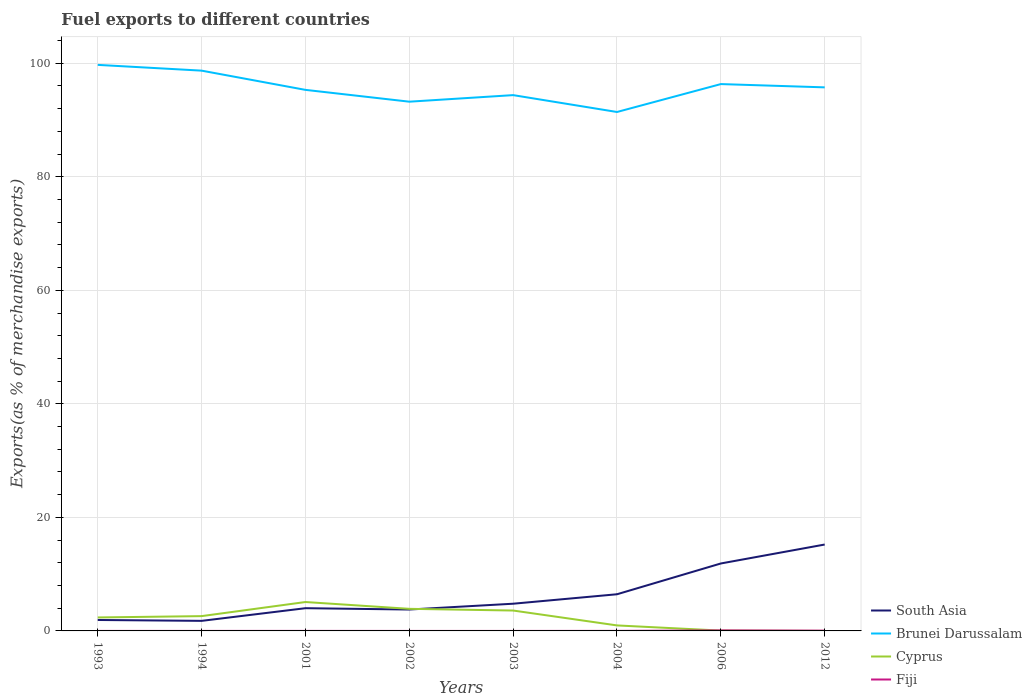Is the number of lines equal to the number of legend labels?
Provide a succinct answer. Yes. Across all years, what is the maximum percentage of exports to different countries in Cyprus?
Provide a succinct answer. 9.987264344271967e-6. In which year was the percentage of exports to different countries in South Asia maximum?
Keep it short and to the point. 1994. What is the total percentage of exports to different countries in South Asia in the graph?
Offer a very short reply. -10.11. What is the difference between the highest and the second highest percentage of exports to different countries in Fiji?
Give a very brief answer. 0.09. Is the percentage of exports to different countries in South Asia strictly greater than the percentage of exports to different countries in Fiji over the years?
Give a very brief answer. No. What is the difference between two consecutive major ticks on the Y-axis?
Ensure brevity in your answer.  20. Does the graph contain grids?
Make the answer very short. Yes. How are the legend labels stacked?
Provide a short and direct response. Vertical. What is the title of the graph?
Your answer should be compact. Fuel exports to different countries. What is the label or title of the Y-axis?
Make the answer very short. Exports(as % of merchandise exports). What is the Exports(as % of merchandise exports) in South Asia in 1993?
Give a very brief answer. 1.93. What is the Exports(as % of merchandise exports) of Brunei Darussalam in 1993?
Keep it short and to the point. 99.71. What is the Exports(as % of merchandise exports) of Cyprus in 1993?
Your answer should be very brief. 2.37. What is the Exports(as % of merchandise exports) in Fiji in 1993?
Your response must be concise. 0. What is the Exports(as % of merchandise exports) in South Asia in 1994?
Offer a terse response. 1.77. What is the Exports(as % of merchandise exports) of Brunei Darussalam in 1994?
Provide a succinct answer. 98.69. What is the Exports(as % of merchandise exports) in Cyprus in 1994?
Offer a very short reply. 2.61. What is the Exports(as % of merchandise exports) of Fiji in 1994?
Keep it short and to the point. 0. What is the Exports(as % of merchandise exports) in South Asia in 2001?
Your answer should be very brief. 4. What is the Exports(as % of merchandise exports) of Brunei Darussalam in 2001?
Your answer should be very brief. 95.31. What is the Exports(as % of merchandise exports) in Cyprus in 2001?
Your response must be concise. 5.09. What is the Exports(as % of merchandise exports) of Fiji in 2001?
Offer a terse response. 0.01. What is the Exports(as % of merchandise exports) in South Asia in 2002?
Your answer should be compact. 3.77. What is the Exports(as % of merchandise exports) of Brunei Darussalam in 2002?
Give a very brief answer. 93.23. What is the Exports(as % of merchandise exports) in Cyprus in 2002?
Offer a very short reply. 3.89. What is the Exports(as % of merchandise exports) of Fiji in 2002?
Your response must be concise. 0. What is the Exports(as % of merchandise exports) of South Asia in 2003?
Offer a very short reply. 4.79. What is the Exports(as % of merchandise exports) in Brunei Darussalam in 2003?
Provide a succinct answer. 94.38. What is the Exports(as % of merchandise exports) in Cyprus in 2003?
Offer a terse response. 3.59. What is the Exports(as % of merchandise exports) in Fiji in 2003?
Provide a short and direct response. 0. What is the Exports(as % of merchandise exports) of South Asia in 2004?
Offer a very short reply. 6.46. What is the Exports(as % of merchandise exports) in Brunei Darussalam in 2004?
Ensure brevity in your answer.  91.41. What is the Exports(as % of merchandise exports) of Cyprus in 2004?
Offer a terse response. 0.97. What is the Exports(as % of merchandise exports) in Fiji in 2004?
Your response must be concise. 0.01. What is the Exports(as % of merchandise exports) of South Asia in 2006?
Ensure brevity in your answer.  11.88. What is the Exports(as % of merchandise exports) in Brunei Darussalam in 2006?
Make the answer very short. 96.33. What is the Exports(as % of merchandise exports) in Cyprus in 2006?
Give a very brief answer. 0.06. What is the Exports(as % of merchandise exports) in Fiji in 2006?
Make the answer very short. 0.09. What is the Exports(as % of merchandise exports) of South Asia in 2012?
Keep it short and to the point. 15.22. What is the Exports(as % of merchandise exports) of Brunei Darussalam in 2012?
Your answer should be compact. 95.75. What is the Exports(as % of merchandise exports) in Cyprus in 2012?
Your answer should be very brief. 9.987264344271967e-6. What is the Exports(as % of merchandise exports) of Fiji in 2012?
Your answer should be very brief. 0.05. Across all years, what is the maximum Exports(as % of merchandise exports) in South Asia?
Keep it short and to the point. 15.22. Across all years, what is the maximum Exports(as % of merchandise exports) in Brunei Darussalam?
Make the answer very short. 99.71. Across all years, what is the maximum Exports(as % of merchandise exports) in Cyprus?
Your answer should be compact. 5.09. Across all years, what is the maximum Exports(as % of merchandise exports) in Fiji?
Make the answer very short. 0.09. Across all years, what is the minimum Exports(as % of merchandise exports) in South Asia?
Offer a terse response. 1.77. Across all years, what is the minimum Exports(as % of merchandise exports) of Brunei Darussalam?
Keep it short and to the point. 91.41. Across all years, what is the minimum Exports(as % of merchandise exports) in Cyprus?
Keep it short and to the point. 9.987264344271967e-6. Across all years, what is the minimum Exports(as % of merchandise exports) in Fiji?
Give a very brief answer. 0. What is the total Exports(as % of merchandise exports) in South Asia in the graph?
Give a very brief answer. 49.82. What is the total Exports(as % of merchandise exports) in Brunei Darussalam in the graph?
Offer a terse response. 764.8. What is the total Exports(as % of merchandise exports) of Cyprus in the graph?
Your answer should be compact. 18.58. What is the total Exports(as % of merchandise exports) in Fiji in the graph?
Your response must be concise. 0.15. What is the difference between the Exports(as % of merchandise exports) in South Asia in 1993 and that in 1994?
Give a very brief answer. 0.15. What is the difference between the Exports(as % of merchandise exports) of Brunei Darussalam in 1993 and that in 1994?
Make the answer very short. 1.02. What is the difference between the Exports(as % of merchandise exports) of Cyprus in 1993 and that in 1994?
Your answer should be compact. -0.24. What is the difference between the Exports(as % of merchandise exports) in Fiji in 1993 and that in 1994?
Provide a succinct answer. 0. What is the difference between the Exports(as % of merchandise exports) in South Asia in 1993 and that in 2001?
Provide a succinct answer. -2.08. What is the difference between the Exports(as % of merchandise exports) in Brunei Darussalam in 1993 and that in 2001?
Your answer should be compact. 4.4. What is the difference between the Exports(as % of merchandise exports) of Cyprus in 1993 and that in 2001?
Your answer should be very brief. -2.72. What is the difference between the Exports(as % of merchandise exports) in Fiji in 1993 and that in 2001?
Your answer should be very brief. -0. What is the difference between the Exports(as % of merchandise exports) of South Asia in 1993 and that in 2002?
Your answer should be very brief. -1.84. What is the difference between the Exports(as % of merchandise exports) of Brunei Darussalam in 1993 and that in 2002?
Keep it short and to the point. 6.48. What is the difference between the Exports(as % of merchandise exports) of Cyprus in 1993 and that in 2002?
Provide a succinct answer. -1.52. What is the difference between the Exports(as % of merchandise exports) of Fiji in 1993 and that in 2002?
Your response must be concise. 0. What is the difference between the Exports(as % of merchandise exports) of South Asia in 1993 and that in 2003?
Your answer should be compact. -2.87. What is the difference between the Exports(as % of merchandise exports) in Brunei Darussalam in 1993 and that in 2003?
Keep it short and to the point. 5.33. What is the difference between the Exports(as % of merchandise exports) in Cyprus in 1993 and that in 2003?
Offer a very short reply. -1.22. What is the difference between the Exports(as % of merchandise exports) in Fiji in 1993 and that in 2003?
Make the answer very short. 0. What is the difference between the Exports(as % of merchandise exports) of South Asia in 1993 and that in 2004?
Ensure brevity in your answer.  -4.53. What is the difference between the Exports(as % of merchandise exports) of Brunei Darussalam in 1993 and that in 2004?
Keep it short and to the point. 8.3. What is the difference between the Exports(as % of merchandise exports) of Cyprus in 1993 and that in 2004?
Offer a terse response. 1.4. What is the difference between the Exports(as % of merchandise exports) of Fiji in 1993 and that in 2004?
Your response must be concise. -0.01. What is the difference between the Exports(as % of merchandise exports) in South Asia in 1993 and that in 2006?
Offer a very short reply. -9.96. What is the difference between the Exports(as % of merchandise exports) in Brunei Darussalam in 1993 and that in 2006?
Your answer should be very brief. 3.38. What is the difference between the Exports(as % of merchandise exports) of Cyprus in 1993 and that in 2006?
Your answer should be very brief. 2.31. What is the difference between the Exports(as % of merchandise exports) in Fiji in 1993 and that in 2006?
Give a very brief answer. -0.09. What is the difference between the Exports(as % of merchandise exports) in South Asia in 1993 and that in 2012?
Give a very brief answer. -13.29. What is the difference between the Exports(as % of merchandise exports) of Brunei Darussalam in 1993 and that in 2012?
Offer a terse response. 3.96. What is the difference between the Exports(as % of merchandise exports) of Cyprus in 1993 and that in 2012?
Your response must be concise. 2.37. What is the difference between the Exports(as % of merchandise exports) in Fiji in 1993 and that in 2012?
Your answer should be compact. -0.04. What is the difference between the Exports(as % of merchandise exports) of South Asia in 1994 and that in 2001?
Offer a terse response. -2.23. What is the difference between the Exports(as % of merchandise exports) in Brunei Darussalam in 1994 and that in 2001?
Provide a succinct answer. 3.39. What is the difference between the Exports(as % of merchandise exports) of Cyprus in 1994 and that in 2001?
Give a very brief answer. -2.48. What is the difference between the Exports(as % of merchandise exports) of Fiji in 1994 and that in 2001?
Make the answer very short. -0. What is the difference between the Exports(as % of merchandise exports) of South Asia in 1994 and that in 2002?
Provide a short and direct response. -2. What is the difference between the Exports(as % of merchandise exports) of Brunei Darussalam in 1994 and that in 2002?
Your answer should be very brief. 5.47. What is the difference between the Exports(as % of merchandise exports) of Cyprus in 1994 and that in 2002?
Make the answer very short. -1.29. What is the difference between the Exports(as % of merchandise exports) in Fiji in 1994 and that in 2002?
Offer a terse response. 0. What is the difference between the Exports(as % of merchandise exports) in South Asia in 1994 and that in 2003?
Make the answer very short. -3.02. What is the difference between the Exports(as % of merchandise exports) of Brunei Darussalam in 1994 and that in 2003?
Provide a short and direct response. 4.31. What is the difference between the Exports(as % of merchandise exports) of Cyprus in 1994 and that in 2003?
Keep it short and to the point. -0.98. What is the difference between the Exports(as % of merchandise exports) in Fiji in 1994 and that in 2003?
Give a very brief answer. 0. What is the difference between the Exports(as % of merchandise exports) of South Asia in 1994 and that in 2004?
Offer a terse response. -4.69. What is the difference between the Exports(as % of merchandise exports) of Brunei Darussalam in 1994 and that in 2004?
Your answer should be compact. 7.28. What is the difference between the Exports(as % of merchandise exports) of Cyprus in 1994 and that in 2004?
Offer a terse response. 1.64. What is the difference between the Exports(as % of merchandise exports) of Fiji in 1994 and that in 2004?
Your answer should be compact. -0.01. What is the difference between the Exports(as % of merchandise exports) in South Asia in 1994 and that in 2006?
Your response must be concise. -10.11. What is the difference between the Exports(as % of merchandise exports) of Brunei Darussalam in 1994 and that in 2006?
Provide a short and direct response. 2.37. What is the difference between the Exports(as % of merchandise exports) in Cyprus in 1994 and that in 2006?
Provide a short and direct response. 2.55. What is the difference between the Exports(as % of merchandise exports) in Fiji in 1994 and that in 2006?
Offer a very short reply. -0.09. What is the difference between the Exports(as % of merchandise exports) of South Asia in 1994 and that in 2012?
Your response must be concise. -13.45. What is the difference between the Exports(as % of merchandise exports) of Brunei Darussalam in 1994 and that in 2012?
Give a very brief answer. 2.95. What is the difference between the Exports(as % of merchandise exports) in Cyprus in 1994 and that in 2012?
Provide a short and direct response. 2.61. What is the difference between the Exports(as % of merchandise exports) in Fiji in 1994 and that in 2012?
Offer a very short reply. -0.04. What is the difference between the Exports(as % of merchandise exports) of South Asia in 2001 and that in 2002?
Your answer should be very brief. 0.23. What is the difference between the Exports(as % of merchandise exports) of Brunei Darussalam in 2001 and that in 2002?
Offer a terse response. 2.08. What is the difference between the Exports(as % of merchandise exports) of Cyprus in 2001 and that in 2002?
Your response must be concise. 1.2. What is the difference between the Exports(as % of merchandise exports) in Fiji in 2001 and that in 2002?
Your answer should be very brief. 0.01. What is the difference between the Exports(as % of merchandise exports) in South Asia in 2001 and that in 2003?
Your answer should be compact. -0.79. What is the difference between the Exports(as % of merchandise exports) in Brunei Darussalam in 2001 and that in 2003?
Provide a succinct answer. 0.92. What is the difference between the Exports(as % of merchandise exports) in Cyprus in 2001 and that in 2003?
Your response must be concise. 1.5. What is the difference between the Exports(as % of merchandise exports) of Fiji in 2001 and that in 2003?
Offer a terse response. 0.01. What is the difference between the Exports(as % of merchandise exports) of South Asia in 2001 and that in 2004?
Offer a terse response. -2.45. What is the difference between the Exports(as % of merchandise exports) of Brunei Darussalam in 2001 and that in 2004?
Offer a terse response. 3.9. What is the difference between the Exports(as % of merchandise exports) of Cyprus in 2001 and that in 2004?
Your answer should be compact. 4.12. What is the difference between the Exports(as % of merchandise exports) of Fiji in 2001 and that in 2004?
Make the answer very short. -0. What is the difference between the Exports(as % of merchandise exports) of South Asia in 2001 and that in 2006?
Ensure brevity in your answer.  -7.88. What is the difference between the Exports(as % of merchandise exports) in Brunei Darussalam in 2001 and that in 2006?
Your response must be concise. -1.02. What is the difference between the Exports(as % of merchandise exports) of Cyprus in 2001 and that in 2006?
Provide a succinct answer. 5.03. What is the difference between the Exports(as % of merchandise exports) of Fiji in 2001 and that in 2006?
Offer a very short reply. -0.08. What is the difference between the Exports(as % of merchandise exports) of South Asia in 2001 and that in 2012?
Give a very brief answer. -11.21. What is the difference between the Exports(as % of merchandise exports) of Brunei Darussalam in 2001 and that in 2012?
Your answer should be very brief. -0.44. What is the difference between the Exports(as % of merchandise exports) in Cyprus in 2001 and that in 2012?
Provide a short and direct response. 5.09. What is the difference between the Exports(as % of merchandise exports) of Fiji in 2001 and that in 2012?
Your answer should be compact. -0.04. What is the difference between the Exports(as % of merchandise exports) of South Asia in 2002 and that in 2003?
Provide a short and direct response. -1.02. What is the difference between the Exports(as % of merchandise exports) of Brunei Darussalam in 2002 and that in 2003?
Offer a very short reply. -1.16. What is the difference between the Exports(as % of merchandise exports) in Cyprus in 2002 and that in 2003?
Ensure brevity in your answer.  0.3. What is the difference between the Exports(as % of merchandise exports) in Fiji in 2002 and that in 2003?
Ensure brevity in your answer.  0. What is the difference between the Exports(as % of merchandise exports) in South Asia in 2002 and that in 2004?
Provide a short and direct response. -2.69. What is the difference between the Exports(as % of merchandise exports) in Brunei Darussalam in 2002 and that in 2004?
Offer a very short reply. 1.82. What is the difference between the Exports(as % of merchandise exports) of Cyprus in 2002 and that in 2004?
Offer a very short reply. 2.92. What is the difference between the Exports(as % of merchandise exports) in Fiji in 2002 and that in 2004?
Your answer should be compact. -0.01. What is the difference between the Exports(as % of merchandise exports) in South Asia in 2002 and that in 2006?
Your answer should be compact. -8.11. What is the difference between the Exports(as % of merchandise exports) in Brunei Darussalam in 2002 and that in 2006?
Keep it short and to the point. -3.1. What is the difference between the Exports(as % of merchandise exports) in Cyprus in 2002 and that in 2006?
Offer a very short reply. 3.84. What is the difference between the Exports(as % of merchandise exports) of Fiji in 2002 and that in 2006?
Provide a succinct answer. -0.09. What is the difference between the Exports(as % of merchandise exports) of South Asia in 2002 and that in 2012?
Your answer should be very brief. -11.45. What is the difference between the Exports(as % of merchandise exports) in Brunei Darussalam in 2002 and that in 2012?
Offer a terse response. -2.52. What is the difference between the Exports(as % of merchandise exports) of Cyprus in 2002 and that in 2012?
Your answer should be compact. 3.89. What is the difference between the Exports(as % of merchandise exports) of Fiji in 2002 and that in 2012?
Keep it short and to the point. -0.05. What is the difference between the Exports(as % of merchandise exports) of South Asia in 2003 and that in 2004?
Give a very brief answer. -1.67. What is the difference between the Exports(as % of merchandise exports) in Brunei Darussalam in 2003 and that in 2004?
Your answer should be compact. 2.97. What is the difference between the Exports(as % of merchandise exports) in Cyprus in 2003 and that in 2004?
Ensure brevity in your answer.  2.62. What is the difference between the Exports(as % of merchandise exports) in Fiji in 2003 and that in 2004?
Give a very brief answer. -0.01. What is the difference between the Exports(as % of merchandise exports) in South Asia in 2003 and that in 2006?
Make the answer very short. -7.09. What is the difference between the Exports(as % of merchandise exports) in Brunei Darussalam in 2003 and that in 2006?
Offer a very short reply. -1.94. What is the difference between the Exports(as % of merchandise exports) of Cyprus in 2003 and that in 2006?
Offer a terse response. 3.53. What is the difference between the Exports(as % of merchandise exports) in Fiji in 2003 and that in 2006?
Your response must be concise. -0.09. What is the difference between the Exports(as % of merchandise exports) of South Asia in 2003 and that in 2012?
Keep it short and to the point. -10.42. What is the difference between the Exports(as % of merchandise exports) of Brunei Darussalam in 2003 and that in 2012?
Your response must be concise. -1.37. What is the difference between the Exports(as % of merchandise exports) in Cyprus in 2003 and that in 2012?
Offer a terse response. 3.59. What is the difference between the Exports(as % of merchandise exports) in Fiji in 2003 and that in 2012?
Your answer should be very brief. -0.05. What is the difference between the Exports(as % of merchandise exports) in South Asia in 2004 and that in 2006?
Your answer should be compact. -5.42. What is the difference between the Exports(as % of merchandise exports) in Brunei Darussalam in 2004 and that in 2006?
Your response must be concise. -4.92. What is the difference between the Exports(as % of merchandise exports) of Cyprus in 2004 and that in 2006?
Provide a short and direct response. 0.91. What is the difference between the Exports(as % of merchandise exports) of Fiji in 2004 and that in 2006?
Your answer should be very brief. -0.08. What is the difference between the Exports(as % of merchandise exports) of South Asia in 2004 and that in 2012?
Your answer should be very brief. -8.76. What is the difference between the Exports(as % of merchandise exports) of Brunei Darussalam in 2004 and that in 2012?
Give a very brief answer. -4.34. What is the difference between the Exports(as % of merchandise exports) in Cyprus in 2004 and that in 2012?
Your response must be concise. 0.97. What is the difference between the Exports(as % of merchandise exports) of Fiji in 2004 and that in 2012?
Keep it short and to the point. -0.04. What is the difference between the Exports(as % of merchandise exports) in South Asia in 2006 and that in 2012?
Your answer should be compact. -3.34. What is the difference between the Exports(as % of merchandise exports) of Brunei Darussalam in 2006 and that in 2012?
Keep it short and to the point. 0.58. What is the difference between the Exports(as % of merchandise exports) of Cyprus in 2006 and that in 2012?
Ensure brevity in your answer.  0.06. What is the difference between the Exports(as % of merchandise exports) of Fiji in 2006 and that in 2012?
Give a very brief answer. 0.04. What is the difference between the Exports(as % of merchandise exports) of South Asia in 1993 and the Exports(as % of merchandise exports) of Brunei Darussalam in 1994?
Give a very brief answer. -96.77. What is the difference between the Exports(as % of merchandise exports) of South Asia in 1993 and the Exports(as % of merchandise exports) of Cyprus in 1994?
Offer a terse response. -0.68. What is the difference between the Exports(as % of merchandise exports) in South Asia in 1993 and the Exports(as % of merchandise exports) in Fiji in 1994?
Your response must be concise. 1.92. What is the difference between the Exports(as % of merchandise exports) in Brunei Darussalam in 1993 and the Exports(as % of merchandise exports) in Cyprus in 1994?
Offer a very short reply. 97.1. What is the difference between the Exports(as % of merchandise exports) in Brunei Darussalam in 1993 and the Exports(as % of merchandise exports) in Fiji in 1994?
Ensure brevity in your answer.  99.71. What is the difference between the Exports(as % of merchandise exports) in Cyprus in 1993 and the Exports(as % of merchandise exports) in Fiji in 1994?
Ensure brevity in your answer.  2.37. What is the difference between the Exports(as % of merchandise exports) in South Asia in 1993 and the Exports(as % of merchandise exports) in Brunei Darussalam in 2001?
Your answer should be compact. -93.38. What is the difference between the Exports(as % of merchandise exports) of South Asia in 1993 and the Exports(as % of merchandise exports) of Cyprus in 2001?
Give a very brief answer. -3.17. What is the difference between the Exports(as % of merchandise exports) of South Asia in 1993 and the Exports(as % of merchandise exports) of Fiji in 2001?
Give a very brief answer. 1.92. What is the difference between the Exports(as % of merchandise exports) in Brunei Darussalam in 1993 and the Exports(as % of merchandise exports) in Cyprus in 2001?
Your response must be concise. 94.62. What is the difference between the Exports(as % of merchandise exports) of Brunei Darussalam in 1993 and the Exports(as % of merchandise exports) of Fiji in 2001?
Your answer should be very brief. 99.7. What is the difference between the Exports(as % of merchandise exports) of Cyprus in 1993 and the Exports(as % of merchandise exports) of Fiji in 2001?
Your response must be concise. 2.37. What is the difference between the Exports(as % of merchandise exports) of South Asia in 1993 and the Exports(as % of merchandise exports) of Brunei Darussalam in 2002?
Make the answer very short. -91.3. What is the difference between the Exports(as % of merchandise exports) of South Asia in 1993 and the Exports(as % of merchandise exports) of Cyprus in 2002?
Offer a terse response. -1.97. What is the difference between the Exports(as % of merchandise exports) of South Asia in 1993 and the Exports(as % of merchandise exports) of Fiji in 2002?
Your response must be concise. 1.92. What is the difference between the Exports(as % of merchandise exports) of Brunei Darussalam in 1993 and the Exports(as % of merchandise exports) of Cyprus in 2002?
Your answer should be compact. 95.82. What is the difference between the Exports(as % of merchandise exports) of Brunei Darussalam in 1993 and the Exports(as % of merchandise exports) of Fiji in 2002?
Give a very brief answer. 99.71. What is the difference between the Exports(as % of merchandise exports) of Cyprus in 1993 and the Exports(as % of merchandise exports) of Fiji in 2002?
Ensure brevity in your answer.  2.37. What is the difference between the Exports(as % of merchandise exports) of South Asia in 1993 and the Exports(as % of merchandise exports) of Brunei Darussalam in 2003?
Ensure brevity in your answer.  -92.46. What is the difference between the Exports(as % of merchandise exports) in South Asia in 1993 and the Exports(as % of merchandise exports) in Cyprus in 2003?
Offer a very short reply. -1.67. What is the difference between the Exports(as % of merchandise exports) of South Asia in 1993 and the Exports(as % of merchandise exports) of Fiji in 2003?
Make the answer very short. 1.92. What is the difference between the Exports(as % of merchandise exports) in Brunei Darussalam in 1993 and the Exports(as % of merchandise exports) in Cyprus in 2003?
Ensure brevity in your answer.  96.12. What is the difference between the Exports(as % of merchandise exports) of Brunei Darussalam in 1993 and the Exports(as % of merchandise exports) of Fiji in 2003?
Make the answer very short. 99.71. What is the difference between the Exports(as % of merchandise exports) in Cyprus in 1993 and the Exports(as % of merchandise exports) in Fiji in 2003?
Offer a very short reply. 2.37. What is the difference between the Exports(as % of merchandise exports) in South Asia in 1993 and the Exports(as % of merchandise exports) in Brunei Darussalam in 2004?
Give a very brief answer. -89.48. What is the difference between the Exports(as % of merchandise exports) in South Asia in 1993 and the Exports(as % of merchandise exports) in Cyprus in 2004?
Provide a succinct answer. 0.96. What is the difference between the Exports(as % of merchandise exports) in South Asia in 1993 and the Exports(as % of merchandise exports) in Fiji in 2004?
Your answer should be very brief. 1.92. What is the difference between the Exports(as % of merchandise exports) of Brunei Darussalam in 1993 and the Exports(as % of merchandise exports) of Cyprus in 2004?
Offer a very short reply. 98.74. What is the difference between the Exports(as % of merchandise exports) of Brunei Darussalam in 1993 and the Exports(as % of merchandise exports) of Fiji in 2004?
Offer a terse response. 99.7. What is the difference between the Exports(as % of merchandise exports) in Cyprus in 1993 and the Exports(as % of merchandise exports) in Fiji in 2004?
Give a very brief answer. 2.36. What is the difference between the Exports(as % of merchandise exports) of South Asia in 1993 and the Exports(as % of merchandise exports) of Brunei Darussalam in 2006?
Provide a succinct answer. -94.4. What is the difference between the Exports(as % of merchandise exports) of South Asia in 1993 and the Exports(as % of merchandise exports) of Cyprus in 2006?
Give a very brief answer. 1.87. What is the difference between the Exports(as % of merchandise exports) in South Asia in 1993 and the Exports(as % of merchandise exports) in Fiji in 2006?
Give a very brief answer. 1.84. What is the difference between the Exports(as % of merchandise exports) of Brunei Darussalam in 1993 and the Exports(as % of merchandise exports) of Cyprus in 2006?
Keep it short and to the point. 99.65. What is the difference between the Exports(as % of merchandise exports) in Brunei Darussalam in 1993 and the Exports(as % of merchandise exports) in Fiji in 2006?
Give a very brief answer. 99.62. What is the difference between the Exports(as % of merchandise exports) of Cyprus in 1993 and the Exports(as % of merchandise exports) of Fiji in 2006?
Provide a succinct answer. 2.28. What is the difference between the Exports(as % of merchandise exports) of South Asia in 1993 and the Exports(as % of merchandise exports) of Brunei Darussalam in 2012?
Your answer should be very brief. -93.82. What is the difference between the Exports(as % of merchandise exports) of South Asia in 1993 and the Exports(as % of merchandise exports) of Cyprus in 2012?
Make the answer very short. 1.93. What is the difference between the Exports(as % of merchandise exports) in South Asia in 1993 and the Exports(as % of merchandise exports) in Fiji in 2012?
Keep it short and to the point. 1.88. What is the difference between the Exports(as % of merchandise exports) in Brunei Darussalam in 1993 and the Exports(as % of merchandise exports) in Cyprus in 2012?
Offer a terse response. 99.71. What is the difference between the Exports(as % of merchandise exports) in Brunei Darussalam in 1993 and the Exports(as % of merchandise exports) in Fiji in 2012?
Ensure brevity in your answer.  99.66. What is the difference between the Exports(as % of merchandise exports) of Cyprus in 1993 and the Exports(as % of merchandise exports) of Fiji in 2012?
Keep it short and to the point. 2.33. What is the difference between the Exports(as % of merchandise exports) of South Asia in 1994 and the Exports(as % of merchandise exports) of Brunei Darussalam in 2001?
Make the answer very short. -93.53. What is the difference between the Exports(as % of merchandise exports) of South Asia in 1994 and the Exports(as % of merchandise exports) of Cyprus in 2001?
Give a very brief answer. -3.32. What is the difference between the Exports(as % of merchandise exports) of South Asia in 1994 and the Exports(as % of merchandise exports) of Fiji in 2001?
Provide a short and direct response. 1.77. What is the difference between the Exports(as % of merchandise exports) of Brunei Darussalam in 1994 and the Exports(as % of merchandise exports) of Cyprus in 2001?
Give a very brief answer. 93.6. What is the difference between the Exports(as % of merchandise exports) of Brunei Darussalam in 1994 and the Exports(as % of merchandise exports) of Fiji in 2001?
Your response must be concise. 98.69. What is the difference between the Exports(as % of merchandise exports) in Cyprus in 1994 and the Exports(as % of merchandise exports) in Fiji in 2001?
Ensure brevity in your answer.  2.6. What is the difference between the Exports(as % of merchandise exports) of South Asia in 1994 and the Exports(as % of merchandise exports) of Brunei Darussalam in 2002?
Your answer should be very brief. -91.45. What is the difference between the Exports(as % of merchandise exports) in South Asia in 1994 and the Exports(as % of merchandise exports) in Cyprus in 2002?
Offer a very short reply. -2.12. What is the difference between the Exports(as % of merchandise exports) in South Asia in 1994 and the Exports(as % of merchandise exports) in Fiji in 2002?
Provide a short and direct response. 1.77. What is the difference between the Exports(as % of merchandise exports) in Brunei Darussalam in 1994 and the Exports(as % of merchandise exports) in Cyprus in 2002?
Give a very brief answer. 94.8. What is the difference between the Exports(as % of merchandise exports) in Brunei Darussalam in 1994 and the Exports(as % of merchandise exports) in Fiji in 2002?
Provide a succinct answer. 98.69. What is the difference between the Exports(as % of merchandise exports) of Cyprus in 1994 and the Exports(as % of merchandise exports) of Fiji in 2002?
Give a very brief answer. 2.61. What is the difference between the Exports(as % of merchandise exports) of South Asia in 1994 and the Exports(as % of merchandise exports) of Brunei Darussalam in 2003?
Your answer should be compact. -92.61. What is the difference between the Exports(as % of merchandise exports) of South Asia in 1994 and the Exports(as % of merchandise exports) of Cyprus in 2003?
Offer a very short reply. -1.82. What is the difference between the Exports(as % of merchandise exports) in South Asia in 1994 and the Exports(as % of merchandise exports) in Fiji in 2003?
Ensure brevity in your answer.  1.77. What is the difference between the Exports(as % of merchandise exports) in Brunei Darussalam in 1994 and the Exports(as % of merchandise exports) in Cyprus in 2003?
Your answer should be very brief. 95.1. What is the difference between the Exports(as % of merchandise exports) of Brunei Darussalam in 1994 and the Exports(as % of merchandise exports) of Fiji in 2003?
Your answer should be very brief. 98.69. What is the difference between the Exports(as % of merchandise exports) of Cyprus in 1994 and the Exports(as % of merchandise exports) of Fiji in 2003?
Keep it short and to the point. 2.61. What is the difference between the Exports(as % of merchandise exports) of South Asia in 1994 and the Exports(as % of merchandise exports) of Brunei Darussalam in 2004?
Ensure brevity in your answer.  -89.64. What is the difference between the Exports(as % of merchandise exports) in South Asia in 1994 and the Exports(as % of merchandise exports) in Cyprus in 2004?
Make the answer very short. 0.8. What is the difference between the Exports(as % of merchandise exports) in South Asia in 1994 and the Exports(as % of merchandise exports) in Fiji in 2004?
Provide a succinct answer. 1.76. What is the difference between the Exports(as % of merchandise exports) of Brunei Darussalam in 1994 and the Exports(as % of merchandise exports) of Cyprus in 2004?
Make the answer very short. 97.72. What is the difference between the Exports(as % of merchandise exports) in Brunei Darussalam in 1994 and the Exports(as % of merchandise exports) in Fiji in 2004?
Make the answer very short. 98.69. What is the difference between the Exports(as % of merchandise exports) of Cyprus in 1994 and the Exports(as % of merchandise exports) of Fiji in 2004?
Provide a short and direct response. 2.6. What is the difference between the Exports(as % of merchandise exports) of South Asia in 1994 and the Exports(as % of merchandise exports) of Brunei Darussalam in 2006?
Your answer should be very brief. -94.55. What is the difference between the Exports(as % of merchandise exports) of South Asia in 1994 and the Exports(as % of merchandise exports) of Cyprus in 2006?
Your response must be concise. 1.71. What is the difference between the Exports(as % of merchandise exports) of South Asia in 1994 and the Exports(as % of merchandise exports) of Fiji in 2006?
Keep it short and to the point. 1.68. What is the difference between the Exports(as % of merchandise exports) of Brunei Darussalam in 1994 and the Exports(as % of merchandise exports) of Cyprus in 2006?
Make the answer very short. 98.64. What is the difference between the Exports(as % of merchandise exports) in Brunei Darussalam in 1994 and the Exports(as % of merchandise exports) in Fiji in 2006?
Your response must be concise. 98.61. What is the difference between the Exports(as % of merchandise exports) of Cyprus in 1994 and the Exports(as % of merchandise exports) of Fiji in 2006?
Ensure brevity in your answer.  2.52. What is the difference between the Exports(as % of merchandise exports) in South Asia in 1994 and the Exports(as % of merchandise exports) in Brunei Darussalam in 2012?
Ensure brevity in your answer.  -93.98. What is the difference between the Exports(as % of merchandise exports) of South Asia in 1994 and the Exports(as % of merchandise exports) of Cyprus in 2012?
Your response must be concise. 1.77. What is the difference between the Exports(as % of merchandise exports) of South Asia in 1994 and the Exports(as % of merchandise exports) of Fiji in 2012?
Your answer should be very brief. 1.73. What is the difference between the Exports(as % of merchandise exports) in Brunei Darussalam in 1994 and the Exports(as % of merchandise exports) in Cyprus in 2012?
Your answer should be very brief. 98.69. What is the difference between the Exports(as % of merchandise exports) of Brunei Darussalam in 1994 and the Exports(as % of merchandise exports) of Fiji in 2012?
Your response must be concise. 98.65. What is the difference between the Exports(as % of merchandise exports) of Cyprus in 1994 and the Exports(as % of merchandise exports) of Fiji in 2012?
Offer a terse response. 2.56. What is the difference between the Exports(as % of merchandise exports) of South Asia in 2001 and the Exports(as % of merchandise exports) of Brunei Darussalam in 2002?
Give a very brief answer. -89.22. What is the difference between the Exports(as % of merchandise exports) of South Asia in 2001 and the Exports(as % of merchandise exports) of Cyprus in 2002?
Make the answer very short. 0.11. What is the difference between the Exports(as % of merchandise exports) of South Asia in 2001 and the Exports(as % of merchandise exports) of Fiji in 2002?
Your answer should be very brief. 4. What is the difference between the Exports(as % of merchandise exports) of Brunei Darussalam in 2001 and the Exports(as % of merchandise exports) of Cyprus in 2002?
Provide a succinct answer. 91.41. What is the difference between the Exports(as % of merchandise exports) of Brunei Darussalam in 2001 and the Exports(as % of merchandise exports) of Fiji in 2002?
Ensure brevity in your answer.  95.31. What is the difference between the Exports(as % of merchandise exports) in Cyprus in 2001 and the Exports(as % of merchandise exports) in Fiji in 2002?
Your answer should be very brief. 5.09. What is the difference between the Exports(as % of merchandise exports) of South Asia in 2001 and the Exports(as % of merchandise exports) of Brunei Darussalam in 2003?
Your answer should be very brief. -90.38. What is the difference between the Exports(as % of merchandise exports) of South Asia in 2001 and the Exports(as % of merchandise exports) of Cyprus in 2003?
Keep it short and to the point. 0.41. What is the difference between the Exports(as % of merchandise exports) in South Asia in 2001 and the Exports(as % of merchandise exports) in Fiji in 2003?
Provide a short and direct response. 4. What is the difference between the Exports(as % of merchandise exports) in Brunei Darussalam in 2001 and the Exports(as % of merchandise exports) in Cyprus in 2003?
Offer a very short reply. 91.71. What is the difference between the Exports(as % of merchandise exports) of Brunei Darussalam in 2001 and the Exports(as % of merchandise exports) of Fiji in 2003?
Your answer should be compact. 95.31. What is the difference between the Exports(as % of merchandise exports) in Cyprus in 2001 and the Exports(as % of merchandise exports) in Fiji in 2003?
Provide a succinct answer. 5.09. What is the difference between the Exports(as % of merchandise exports) of South Asia in 2001 and the Exports(as % of merchandise exports) of Brunei Darussalam in 2004?
Offer a terse response. -87.41. What is the difference between the Exports(as % of merchandise exports) of South Asia in 2001 and the Exports(as % of merchandise exports) of Cyprus in 2004?
Your answer should be very brief. 3.03. What is the difference between the Exports(as % of merchandise exports) of South Asia in 2001 and the Exports(as % of merchandise exports) of Fiji in 2004?
Offer a very short reply. 4. What is the difference between the Exports(as % of merchandise exports) of Brunei Darussalam in 2001 and the Exports(as % of merchandise exports) of Cyprus in 2004?
Your answer should be compact. 94.34. What is the difference between the Exports(as % of merchandise exports) in Brunei Darussalam in 2001 and the Exports(as % of merchandise exports) in Fiji in 2004?
Make the answer very short. 95.3. What is the difference between the Exports(as % of merchandise exports) of Cyprus in 2001 and the Exports(as % of merchandise exports) of Fiji in 2004?
Your answer should be compact. 5.08. What is the difference between the Exports(as % of merchandise exports) in South Asia in 2001 and the Exports(as % of merchandise exports) in Brunei Darussalam in 2006?
Make the answer very short. -92.32. What is the difference between the Exports(as % of merchandise exports) of South Asia in 2001 and the Exports(as % of merchandise exports) of Cyprus in 2006?
Give a very brief answer. 3.95. What is the difference between the Exports(as % of merchandise exports) of South Asia in 2001 and the Exports(as % of merchandise exports) of Fiji in 2006?
Provide a succinct answer. 3.92. What is the difference between the Exports(as % of merchandise exports) of Brunei Darussalam in 2001 and the Exports(as % of merchandise exports) of Cyprus in 2006?
Provide a short and direct response. 95.25. What is the difference between the Exports(as % of merchandise exports) in Brunei Darussalam in 2001 and the Exports(as % of merchandise exports) in Fiji in 2006?
Provide a short and direct response. 95.22. What is the difference between the Exports(as % of merchandise exports) in Cyprus in 2001 and the Exports(as % of merchandise exports) in Fiji in 2006?
Provide a short and direct response. 5. What is the difference between the Exports(as % of merchandise exports) of South Asia in 2001 and the Exports(as % of merchandise exports) of Brunei Darussalam in 2012?
Provide a short and direct response. -91.75. What is the difference between the Exports(as % of merchandise exports) in South Asia in 2001 and the Exports(as % of merchandise exports) in Cyprus in 2012?
Provide a succinct answer. 4. What is the difference between the Exports(as % of merchandise exports) in South Asia in 2001 and the Exports(as % of merchandise exports) in Fiji in 2012?
Provide a short and direct response. 3.96. What is the difference between the Exports(as % of merchandise exports) in Brunei Darussalam in 2001 and the Exports(as % of merchandise exports) in Cyprus in 2012?
Provide a short and direct response. 95.31. What is the difference between the Exports(as % of merchandise exports) of Brunei Darussalam in 2001 and the Exports(as % of merchandise exports) of Fiji in 2012?
Make the answer very short. 95.26. What is the difference between the Exports(as % of merchandise exports) in Cyprus in 2001 and the Exports(as % of merchandise exports) in Fiji in 2012?
Your answer should be very brief. 5.04. What is the difference between the Exports(as % of merchandise exports) of South Asia in 2002 and the Exports(as % of merchandise exports) of Brunei Darussalam in 2003?
Ensure brevity in your answer.  -90.61. What is the difference between the Exports(as % of merchandise exports) in South Asia in 2002 and the Exports(as % of merchandise exports) in Cyprus in 2003?
Your response must be concise. 0.18. What is the difference between the Exports(as % of merchandise exports) in South Asia in 2002 and the Exports(as % of merchandise exports) in Fiji in 2003?
Offer a terse response. 3.77. What is the difference between the Exports(as % of merchandise exports) of Brunei Darussalam in 2002 and the Exports(as % of merchandise exports) of Cyprus in 2003?
Ensure brevity in your answer.  89.63. What is the difference between the Exports(as % of merchandise exports) of Brunei Darussalam in 2002 and the Exports(as % of merchandise exports) of Fiji in 2003?
Give a very brief answer. 93.23. What is the difference between the Exports(as % of merchandise exports) of Cyprus in 2002 and the Exports(as % of merchandise exports) of Fiji in 2003?
Provide a succinct answer. 3.89. What is the difference between the Exports(as % of merchandise exports) in South Asia in 2002 and the Exports(as % of merchandise exports) in Brunei Darussalam in 2004?
Give a very brief answer. -87.64. What is the difference between the Exports(as % of merchandise exports) in South Asia in 2002 and the Exports(as % of merchandise exports) in Cyprus in 2004?
Your answer should be very brief. 2.8. What is the difference between the Exports(as % of merchandise exports) in South Asia in 2002 and the Exports(as % of merchandise exports) in Fiji in 2004?
Your response must be concise. 3.76. What is the difference between the Exports(as % of merchandise exports) of Brunei Darussalam in 2002 and the Exports(as % of merchandise exports) of Cyprus in 2004?
Make the answer very short. 92.26. What is the difference between the Exports(as % of merchandise exports) in Brunei Darussalam in 2002 and the Exports(as % of merchandise exports) in Fiji in 2004?
Your answer should be compact. 93.22. What is the difference between the Exports(as % of merchandise exports) of Cyprus in 2002 and the Exports(as % of merchandise exports) of Fiji in 2004?
Offer a terse response. 3.88. What is the difference between the Exports(as % of merchandise exports) of South Asia in 2002 and the Exports(as % of merchandise exports) of Brunei Darussalam in 2006?
Your answer should be compact. -92.56. What is the difference between the Exports(as % of merchandise exports) of South Asia in 2002 and the Exports(as % of merchandise exports) of Cyprus in 2006?
Your response must be concise. 3.71. What is the difference between the Exports(as % of merchandise exports) of South Asia in 2002 and the Exports(as % of merchandise exports) of Fiji in 2006?
Provide a succinct answer. 3.68. What is the difference between the Exports(as % of merchandise exports) of Brunei Darussalam in 2002 and the Exports(as % of merchandise exports) of Cyprus in 2006?
Keep it short and to the point. 93.17. What is the difference between the Exports(as % of merchandise exports) of Brunei Darussalam in 2002 and the Exports(as % of merchandise exports) of Fiji in 2006?
Your response must be concise. 93.14. What is the difference between the Exports(as % of merchandise exports) in Cyprus in 2002 and the Exports(as % of merchandise exports) in Fiji in 2006?
Your response must be concise. 3.8. What is the difference between the Exports(as % of merchandise exports) of South Asia in 2002 and the Exports(as % of merchandise exports) of Brunei Darussalam in 2012?
Ensure brevity in your answer.  -91.98. What is the difference between the Exports(as % of merchandise exports) of South Asia in 2002 and the Exports(as % of merchandise exports) of Cyprus in 2012?
Ensure brevity in your answer.  3.77. What is the difference between the Exports(as % of merchandise exports) of South Asia in 2002 and the Exports(as % of merchandise exports) of Fiji in 2012?
Your response must be concise. 3.72. What is the difference between the Exports(as % of merchandise exports) of Brunei Darussalam in 2002 and the Exports(as % of merchandise exports) of Cyprus in 2012?
Offer a terse response. 93.23. What is the difference between the Exports(as % of merchandise exports) in Brunei Darussalam in 2002 and the Exports(as % of merchandise exports) in Fiji in 2012?
Provide a succinct answer. 93.18. What is the difference between the Exports(as % of merchandise exports) in Cyprus in 2002 and the Exports(as % of merchandise exports) in Fiji in 2012?
Your response must be concise. 3.85. What is the difference between the Exports(as % of merchandise exports) of South Asia in 2003 and the Exports(as % of merchandise exports) of Brunei Darussalam in 2004?
Your response must be concise. -86.62. What is the difference between the Exports(as % of merchandise exports) of South Asia in 2003 and the Exports(as % of merchandise exports) of Cyprus in 2004?
Your answer should be compact. 3.82. What is the difference between the Exports(as % of merchandise exports) in South Asia in 2003 and the Exports(as % of merchandise exports) in Fiji in 2004?
Keep it short and to the point. 4.78. What is the difference between the Exports(as % of merchandise exports) in Brunei Darussalam in 2003 and the Exports(as % of merchandise exports) in Cyprus in 2004?
Offer a terse response. 93.41. What is the difference between the Exports(as % of merchandise exports) of Brunei Darussalam in 2003 and the Exports(as % of merchandise exports) of Fiji in 2004?
Keep it short and to the point. 94.37. What is the difference between the Exports(as % of merchandise exports) of Cyprus in 2003 and the Exports(as % of merchandise exports) of Fiji in 2004?
Give a very brief answer. 3.58. What is the difference between the Exports(as % of merchandise exports) in South Asia in 2003 and the Exports(as % of merchandise exports) in Brunei Darussalam in 2006?
Ensure brevity in your answer.  -91.53. What is the difference between the Exports(as % of merchandise exports) in South Asia in 2003 and the Exports(as % of merchandise exports) in Cyprus in 2006?
Offer a terse response. 4.73. What is the difference between the Exports(as % of merchandise exports) of South Asia in 2003 and the Exports(as % of merchandise exports) of Fiji in 2006?
Provide a succinct answer. 4.7. What is the difference between the Exports(as % of merchandise exports) in Brunei Darussalam in 2003 and the Exports(as % of merchandise exports) in Cyprus in 2006?
Your answer should be very brief. 94.32. What is the difference between the Exports(as % of merchandise exports) in Brunei Darussalam in 2003 and the Exports(as % of merchandise exports) in Fiji in 2006?
Provide a succinct answer. 94.29. What is the difference between the Exports(as % of merchandise exports) of Cyprus in 2003 and the Exports(as % of merchandise exports) of Fiji in 2006?
Offer a terse response. 3.5. What is the difference between the Exports(as % of merchandise exports) of South Asia in 2003 and the Exports(as % of merchandise exports) of Brunei Darussalam in 2012?
Your response must be concise. -90.96. What is the difference between the Exports(as % of merchandise exports) of South Asia in 2003 and the Exports(as % of merchandise exports) of Cyprus in 2012?
Make the answer very short. 4.79. What is the difference between the Exports(as % of merchandise exports) of South Asia in 2003 and the Exports(as % of merchandise exports) of Fiji in 2012?
Provide a succinct answer. 4.75. What is the difference between the Exports(as % of merchandise exports) of Brunei Darussalam in 2003 and the Exports(as % of merchandise exports) of Cyprus in 2012?
Your answer should be compact. 94.38. What is the difference between the Exports(as % of merchandise exports) in Brunei Darussalam in 2003 and the Exports(as % of merchandise exports) in Fiji in 2012?
Your response must be concise. 94.34. What is the difference between the Exports(as % of merchandise exports) in Cyprus in 2003 and the Exports(as % of merchandise exports) in Fiji in 2012?
Make the answer very short. 3.55. What is the difference between the Exports(as % of merchandise exports) of South Asia in 2004 and the Exports(as % of merchandise exports) of Brunei Darussalam in 2006?
Keep it short and to the point. -89.87. What is the difference between the Exports(as % of merchandise exports) of South Asia in 2004 and the Exports(as % of merchandise exports) of Cyprus in 2006?
Provide a short and direct response. 6.4. What is the difference between the Exports(as % of merchandise exports) in South Asia in 2004 and the Exports(as % of merchandise exports) in Fiji in 2006?
Provide a succinct answer. 6.37. What is the difference between the Exports(as % of merchandise exports) in Brunei Darussalam in 2004 and the Exports(as % of merchandise exports) in Cyprus in 2006?
Ensure brevity in your answer.  91.35. What is the difference between the Exports(as % of merchandise exports) in Brunei Darussalam in 2004 and the Exports(as % of merchandise exports) in Fiji in 2006?
Offer a terse response. 91.32. What is the difference between the Exports(as % of merchandise exports) of Cyprus in 2004 and the Exports(as % of merchandise exports) of Fiji in 2006?
Offer a very short reply. 0.88. What is the difference between the Exports(as % of merchandise exports) of South Asia in 2004 and the Exports(as % of merchandise exports) of Brunei Darussalam in 2012?
Offer a terse response. -89.29. What is the difference between the Exports(as % of merchandise exports) of South Asia in 2004 and the Exports(as % of merchandise exports) of Cyprus in 2012?
Keep it short and to the point. 6.46. What is the difference between the Exports(as % of merchandise exports) of South Asia in 2004 and the Exports(as % of merchandise exports) of Fiji in 2012?
Give a very brief answer. 6.41. What is the difference between the Exports(as % of merchandise exports) of Brunei Darussalam in 2004 and the Exports(as % of merchandise exports) of Cyprus in 2012?
Make the answer very short. 91.41. What is the difference between the Exports(as % of merchandise exports) in Brunei Darussalam in 2004 and the Exports(as % of merchandise exports) in Fiji in 2012?
Ensure brevity in your answer.  91.36. What is the difference between the Exports(as % of merchandise exports) of Cyprus in 2004 and the Exports(as % of merchandise exports) of Fiji in 2012?
Your response must be concise. 0.92. What is the difference between the Exports(as % of merchandise exports) in South Asia in 2006 and the Exports(as % of merchandise exports) in Brunei Darussalam in 2012?
Offer a very short reply. -83.87. What is the difference between the Exports(as % of merchandise exports) in South Asia in 2006 and the Exports(as % of merchandise exports) in Cyprus in 2012?
Your response must be concise. 11.88. What is the difference between the Exports(as % of merchandise exports) of South Asia in 2006 and the Exports(as % of merchandise exports) of Fiji in 2012?
Make the answer very short. 11.84. What is the difference between the Exports(as % of merchandise exports) of Brunei Darussalam in 2006 and the Exports(as % of merchandise exports) of Cyprus in 2012?
Make the answer very short. 96.33. What is the difference between the Exports(as % of merchandise exports) of Brunei Darussalam in 2006 and the Exports(as % of merchandise exports) of Fiji in 2012?
Your answer should be compact. 96.28. What is the difference between the Exports(as % of merchandise exports) of Cyprus in 2006 and the Exports(as % of merchandise exports) of Fiji in 2012?
Your answer should be compact. 0.01. What is the average Exports(as % of merchandise exports) in South Asia per year?
Offer a terse response. 6.23. What is the average Exports(as % of merchandise exports) in Brunei Darussalam per year?
Give a very brief answer. 95.6. What is the average Exports(as % of merchandise exports) in Cyprus per year?
Keep it short and to the point. 2.32. What is the average Exports(as % of merchandise exports) of Fiji per year?
Your response must be concise. 0.02. In the year 1993, what is the difference between the Exports(as % of merchandise exports) in South Asia and Exports(as % of merchandise exports) in Brunei Darussalam?
Give a very brief answer. -97.78. In the year 1993, what is the difference between the Exports(as % of merchandise exports) in South Asia and Exports(as % of merchandise exports) in Cyprus?
Your answer should be compact. -0.45. In the year 1993, what is the difference between the Exports(as % of merchandise exports) in South Asia and Exports(as % of merchandise exports) in Fiji?
Offer a terse response. 1.92. In the year 1993, what is the difference between the Exports(as % of merchandise exports) of Brunei Darussalam and Exports(as % of merchandise exports) of Cyprus?
Make the answer very short. 97.34. In the year 1993, what is the difference between the Exports(as % of merchandise exports) of Brunei Darussalam and Exports(as % of merchandise exports) of Fiji?
Your response must be concise. 99.71. In the year 1993, what is the difference between the Exports(as % of merchandise exports) of Cyprus and Exports(as % of merchandise exports) of Fiji?
Your answer should be compact. 2.37. In the year 1994, what is the difference between the Exports(as % of merchandise exports) in South Asia and Exports(as % of merchandise exports) in Brunei Darussalam?
Your answer should be compact. -96.92. In the year 1994, what is the difference between the Exports(as % of merchandise exports) of South Asia and Exports(as % of merchandise exports) of Cyprus?
Provide a short and direct response. -0.83. In the year 1994, what is the difference between the Exports(as % of merchandise exports) of South Asia and Exports(as % of merchandise exports) of Fiji?
Ensure brevity in your answer.  1.77. In the year 1994, what is the difference between the Exports(as % of merchandise exports) in Brunei Darussalam and Exports(as % of merchandise exports) in Cyprus?
Your answer should be very brief. 96.09. In the year 1994, what is the difference between the Exports(as % of merchandise exports) of Brunei Darussalam and Exports(as % of merchandise exports) of Fiji?
Provide a succinct answer. 98.69. In the year 1994, what is the difference between the Exports(as % of merchandise exports) in Cyprus and Exports(as % of merchandise exports) in Fiji?
Your answer should be very brief. 2.61. In the year 2001, what is the difference between the Exports(as % of merchandise exports) in South Asia and Exports(as % of merchandise exports) in Brunei Darussalam?
Give a very brief answer. -91.3. In the year 2001, what is the difference between the Exports(as % of merchandise exports) in South Asia and Exports(as % of merchandise exports) in Cyprus?
Ensure brevity in your answer.  -1.09. In the year 2001, what is the difference between the Exports(as % of merchandise exports) in South Asia and Exports(as % of merchandise exports) in Fiji?
Provide a succinct answer. 4. In the year 2001, what is the difference between the Exports(as % of merchandise exports) in Brunei Darussalam and Exports(as % of merchandise exports) in Cyprus?
Your answer should be compact. 90.22. In the year 2001, what is the difference between the Exports(as % of merchandise exports) in Brunei Darussalam and Exports(as % of merchandise exports) in Fiji?
Offer a very short reply. 95.3. In the year 2001, what is the difference between the Exports(as % of merchandise exports) in Cyprus and Exports(as % of merchandise exports) in Fiji?
Provide a short and direct response. 5.08. In the year 2002, what is the difference between the Exports(as % of merchandise exports) in South Asia and Exports(as % of merchandise exports) in Brunei Darussalam?
Provide a succinct answer. -89.46. In the year 2002, what is the difference between the Exports(as % of merchandise exports) in South Asia and Exports(as % of merchandise exports) in Cyprus?
Offer a terse response. -0.12. In the year 2002, what is the difference between the Exports(as % of merchandise exports) of South Asia and Exports(as % of merchandise exports) of Fiji?
Ensure brevity in your answer.  3.77. In the year 2002, what is the difference between the Exports(as % of merchandise exports) of Brunei Darussalam and Exports(as % of merchandise exports) of Cyprus?
Provide a succinct answer. 89.33. In the year 2002, what is the difference between the Exports(as % of merchandise exports) in Brunei Darussalam and Exports(as % of merchandise exports) in Fiji?
Make the answer very short. 93.22. In the year 2002, what is the difference between the Exports(as % of merchandise exports) of Cyprus and Exports(as % of merchandise exports) of Fiji?
Provide a short and direct response. 3.89. In the year 2003, what is the difference between the Exports(as % of merchandise exports) in South Asia and Exports(as % of merchandise exports) in Brunei Darussalam?
Your answer should be very brief. -89.59. In the year 2003, what is the difference between the Exports(as % of merchandise exports) of South Asia and Exports(as % of merchandise exports) of Cyprus?
Offer a very short reply. 1.2. In the year 2003, what is the difference between the Exports(as % of merchandise exports) in South Asia and Exports(as % of merchandise exports) in Fiji?
Provide a short and direct response. 4.79. In the year 2003, what is the difference between the Exports(as % of merchandise exports) of Brunei Darussalam and Exports(as % of merchandise exports) of Cyprus?
Your response must be concise. 90.79. In the year 2003, what is the difference between the Exports(as % of merchandise exports) of Brunei Darussalam and Exports(as % of merchandise exports) of Fiji?
Your answer should be compact. 94.38. In the year 2003, what is the difference between the Exports(as % of merchandise exports) in Cyprus and Exports(as % of merchandise exports) in Fiji?
Your response must be concise. 3.59. In the year 2004, what is the difference between the Exports(as % of merchandise exports) of South Asia and Exports(as % of merchandise exports) of Brunei Darussalam?
Your response must be concise. -84.95. In the year 2004, what is the difference between the Exports(as % of merchandise exports) of South Asia and Exports(as % of merchandise exports) of Cyprus?
Make the answer very short. 5.49. In the year 2004, what is the difference between the Exports(as % of merchandise exports) in South Asia and Exports(as % of merchandise exports) in Fiji?
Offer a terse response. 6.45. In the year 2004, what is the difference between the Exports(as % of merchandise exports) in Brunei Darussalam and Exports(as % of merchandise exports) in Cyprus?
Your answer should be compact. 90.44. In the year 2004, what is the difference between the Exports(as % of merchandise exports) of Brunei Darussalam and Exports(as % of merchandise exports) of Fiji?
Your answer should be compact. 91.4. In the year 2004, what is the difference between the Exports(as % of merchandise exports) in Cyprus and Exports(as % of merchandise exports) in Fiji?
Your answer should be compact. 0.96. In the year 2006, what is the difference between the Exports(as % of merchandise exports) of South Asia and Exports(as % of merchandise exports) of Brunei Darussalam?
Keep it short and to the point. -84.44. In the year 2006, what is the difference between the Exports(as % of merchandise exports) of South Asia and Exports(as % of merchandise exports) of Cyprus?
Give a very brief answer. 11.82. In the year 2006, what is the difference between the Exports(as % of merchandise exports) in South Asia and Exports(as % of merchandise exports) in Fiji?
Your response must be concise. 11.79. In the year 2006, what is the difference between the Exports(as % of merchandise exports) in Brunei Darussalam and Exports(as % of merchandise exports) in Cyprus?
Keep it short and to the point. 96.27. In the year 2006, what is the difference between the Exports(as % of merchandise exports) of Brunei Darussalam and Exports(as % of merchandise exports) of Fiji?
Your answer should be compact. 96.24. In the year 2006, what is the difference between the Exports(as % of merchandise exports) of Cyprus and Exports(as % of merchandise exports) of Fiji?
Your response must be concise. -0.03. In the year 2012, what is the difference between the Exports(as % of merchandise exports) in South Asia and Exports(as % of merchandise exports) in Brunei Darussalam?
Your answer should be very brief. -80.53. In the year 2012, what is the difference between the Exports(as % of merchandise exports) in South Asia and Exports(as % of merchandise exports) in Cyprus?
Give a very brief answer. 15.22. In the year 2012, what is the difference between the Exports(as % of merchandise exports) of South Asia and Exports(as % of merchandise exports) of Fiji?
Your answer should be very brief. 15.17. In the year 2012, what is the difference between the Exports(as % of merchandise exports) in Brunei Darussalam and Exports(as % of merchandise exports) in Cyprus?
Offer a terse response. 95.75. In the year 2012, what is the difference between the Exports(as % of merchandise exports) in Brunei Darussalam and Exports(as % of merchandise exports) in Fiji?
Your answer should be very brief. 95.7. In the year 2012, what is the difference between the Exports(as % of merchandise exports) of Cyprus and Exports(as % of merchandise exports) of Fiji?
Your answer should be compact. -0.05. What is the ratio of the Exports(as % of merchandise exports) in South Asia in 1993 to that in 1994?
Keep it short and to the point. 1.09. What is the ratio of the Exports(as % of merchandise exports) in Brunei Darussalam in 1993 to that in 1994?
Provide a succinct answer. 1.01. What is the ratio of the Exports(as % of merchandise exports) of Cyprus in 1993 to that in 1994?
Provide a succinct answer. 0.91. What is the ratio of the Exports(as % of merchandise exports) in Fiji in 1993 to that in 1994?
Your answer should be compact. 1.03. What is the ratio of the Exports(as % of merchandise exports) of South Asia in 1993 to that in 2001?
Offer a very short reply. 0.48. What is the ratio of the Exports(as % of merchandise exports) in Brunei Darussalam in 1993 to that in 2001?
Your answer should be very brief. 1.05. What is the ratio of the Exports(as % of merchandise exports) in Cyprus in 1993 to that in 2001?
Ensure brevity in your answer.  0.47. What is the ratio of the Exports(as % of merchandise exports) of Fiji in 1993 to that in 2001?
Make the answer very short. 0.23. What is the ratio of the Exports(as % of merchandise exports) of South Asia in 1993 to that in 2002?
Your answer should be compact. 0.51. What is the ratio of the Exports(as % of merchandise exports) in Brunei Darussalam in 1993 to that in 2002?
Your answer should be compact. 1.07. What is the ratio of the Exports(as % of merchandise exports) in Cyprus in 1993 to that in 2002?
Ensure brevity in your answer.  0.61. What is the ratio of the Exports(as % of merchandise exports) in Fiji in 1993 to that in 2002?
Offer a very short reply. 1.95. What is the ratio of the Exports(as % of merchandise exports) in South Asia in 1993 to that in 2003?
Your answer should be compact. 0.4. What is the ratio of the Exports(as % of merchandise exports) of Brunei Darussalam in 1993 to that in 2003?
Provide a succinct answer. 1.06. What is the ratio of the Exports(as % of merchandise exports) in Cyprus in 1993 to that in 2003?
Provide a short and direct response. 0.66. What is the ratio of the Exports(as % of merchandise exports) of Fiji in 1993 to that in 2003?
Provide a succinct answer. 2.98. What is the ratio of the Exports(as % of merchandise exports) of South Asia in 1993 to that in 2004?
Give a very brief answer. 0.3. What is the ratio of the Exports(as % of merchandise exports) of Brunei Darussalam in 1993 to that in 2004?
Make the answer very short. 1.09. What is the ratio of the Exports(as % of merchandise exports) of Cyprus in 1993 to that in 2004?
Your response must be concise. 2.45. What is the ratio of the Exports(as % of merchandise exports) of Fiji in 1993 to that in 2004?
Provide a short and direct response. 0.17. What is the ratio of the Exports(as % of merchandise exports) in South Asia in 1993 to that in 2006?
Keep it short and to the point. 0.16. What is the ratio of the Exports(as % of merchandise exports) of Brunei Darussalam in 1993 to that in 2006?
Offer a terse response. 1.04. What is the ratio of the Exports(as % of merchandise exports) in Cyprus in 1993 to that in 2006?
Offer a terse response. 41.24. What is the ratio of the Exports(as % of merchandise exports) in Fiji in 1993 to that in 2006?
Your answer should be compact. 0.02. What is the ratio of the Exports(as % of merchandise exports) in South Asia in 1993 to that in 2012?
Provide a short and direct response. 0.13. What is the ratio of the Exports(as % of merchandise exports) in Brunei Darussalam in 1993 to that in 2012?
Offer a terse response. 1.04. What is the ratio of the Exports(as % of merchandise exports) of Cyprus in 1993 to that in 2012?
Your answer should be compact. 2.37e+05. What is the ratio of the Exports(as % of merchandise exports) of Fiji in 1993 to that in 2012?
Make the answer very short. 0.03. What is the ratio of the Exports(as % of merchandise exports) of South Asia in 1994 to that in 2001?
Give a very brief answer. 0.44. What is the ratio of the Exports(as % of merchandise exports) in Brunei Darussalam in 1994 to that in 2001?
Make the answer very short. 1.04. What is the ratio of the Exports(as % of merchandise exports) in Cyprus in 1994 to that in 2001?
Your answer should be very brief. 0.51. What is the ratio of the Exports(as % of merchandise exports) of Fiji in 1994 to that in 2001?
Give a very brief answer. 0.22. What is the ratio of the Exports(as % of merchandise exports) of South Asia in 1994 to that in 2002?
Provide a succinct answer. 0.47. What is the ratio of the Exports(as % of merchandise exports) in Brunei Darussalam in 1994 to that in 2002?
Make the answer very short. 1.06. What is the ratio of the Exports(as % of merchandise exports) of Cyprus in 1994 to that in 2002?
Provide a succinct answer. 0.67. What is the ratio of the Exports(as % of merchandise exports) of Fiji in 1994 to that in 2002?
Offer a terse response. 1.89. What is the ratio of the Exports(as % of merchandise exports) of South Asia in 1994 to that in 2003?
Your response must be concise. 0.37. What is the ratio of the Exports(as % of merchandise exports) of Brunei Darussalam in 1994 to that in 2003?
Provide a succinct answer. 1.05. What is the ratio of the Exports(as % of merchandise exports) of Cyprus in 1994 to that in 2003?
Give a very brief answer. 0.73. What is the ratio of the Exports(as % of merchandise exports) in Fiji in 1994 to that in 2003?
Offer a very short reply. 2.88. What is the ratio of the Exports(as % of merchandise exports) in South Asia in 1994 to that in 2004?
Ensure brevity in your answer.  0.27. What is the ratio of the Exports(as % of merchandise exports) of Brunei Darussalam in 1994 to that in 2004?
Provide a succinct answer. 1.08. What is the ratio of the Exports(as % of merchandise exports) of Cyprus in 1994 to that in 2004?
Your response must be concise. 2.69. What is the ratio of the Exports(as % of merchandise exports) of Fiji in 1994 to that in 2004?
Offer a very short reply. 0.16. What is the ratio of the Exports(as % of merchandise exports) of South Asia in 1994 to that in 2006?
Offer a terse response. 0.15. What is the ratio of the Exports(as % of merchandise exports) of Brunei Darussalam in 1994 to that in 2006?
Your answer should be very brief. 1.02. What is the ratio of the Exports(as % of merchandise exports) in Cyprus in 1994 to that in 2006?
Offer a terse response. 45.33. What is the ratio of the Exports(as % of merchandise exports) of Fiji in 1994 to that in 2006?
Your answer should be compact. 0.02. What is the ratio of the Exports(as % of merchandise exports) of South Asia in 1994 to that in 2012?
Keep it short and to the point. 0.12. What is the ratio of the Exports(as % of merchandise exports) of Brunei Darussalam in 1994 to that in 2012?
Offer a very short reply. 1.03. What is the ratio of the Exports(as % of merchandise exports) of Cyprus in 1994 to that in 2012?
Keep it short and to the point. 2.61e+05. What is the ratio of the Exports(as % of merchandise exports) in Fiji in 1994 to that in 2012?
Offer a terse response. 0.03. What is the ratio of the Exports(as % of merchandise exports) of South Asia in 2001 to that in 2002?
Offer a terse response. 1.06. What is the ratio of the Exports(as % of merchandise exports) of Brunei Darussalam in 2001 to that in 2002?
Keep it short and to the point. 1.02. What is the ratio of the Exports(as % of merchandise exports) in Cyprus in 2001 to that in 2002?
Your response must be concise. 1.31. What is the ratio of the Exports(as % of merchandise exports) of Fiji in 2001 to that in 2002?
Provide a succinct answer. 8.51. What is the ratio of the Exports(as % of merchandise exports) of South Asia in 2001 to that in 2003?
Your response must be concise. 0.84. What is the ratio of the Exports(as % of merchandise exports) of Brunei Darussalam in 2001 to that in 2003?
Ensure brevity in your answer.  1.01. What is the ratio of the Exports(as % of merchandise exports) in Cyprus in 2001 to that in 2003?
Offer a very short reply. 1.42. What is the ratio of the Exports(as % of merchandise exports) of Fiji in 2001 to that in 2003?
Offer a terse response. 12.98. What is the ratio of the Exports(as % of merchandise exports) of South Asia in 2001 to that in 2004?
Your answer should be compact. 0.62. What is the ratio of the Exports(as % of merchandise exports) of Brunei Darussalam in 2001 to that in 2004?
Give a very brief answer. 1.04. What is the ratio of the Exports(as % of merchandise exports) in Cyprus in 2001 to that in 2004?
Provide a succinct answer. 5.25. What is the ratio of the Exports(as % of merchandise exports) in Fiji in 2001 to that in 2004?
Your answer should be very brief. 0.72. What is the ratio of the Exports(as % of merchandise exports) of South Asia in 2001 to that in 2006?
Offer a very short reply. 0.34. What is the ratio of the Exports(as % of merchandise exports) of Cyprus in 2001 to that in 2006?
Your answer should be very brief. 88.51. What is the ratio of the Exports(as % of merchandise exports) of Fiji in 2001 to that in 2006?
Your answer should be compact. 0.07. What is the ratio of the Exports(as % of merchandise exports) in South Asia in 2001 to that in 2012?
Your answer should be compact. 0.26. What is the ratio of the Exports(as % of merchandise exports) of Brunei Darussalam in 2001 to that in 2012?
Provide a short and direct response. 1. What is the ratio of the Exports(as % of merchandise exports) in Cyprus in 2001 to that in 2012?
Offer a terse response. 5.10e+05. What is the ratio of the Exports(as % of merchandise exports) in Fiji in 2001 to that in 2012?
Give a very brief answer. 0.13. What is the ratio of the Exports(as % of merchandise exports) in South Asia in 2002 to that in 2003?
Keep it short and to the point. 0.79. What is the ratio of the Exports(as % of merchandise exports) of Brunei Darussalam in 2002 to that in 2003?
Your answer should be compact. 0.99. What is the ratio of the Exports(as % of merchandise exports) of Cyprus in 2002 to that in 2003?
Your answer should be compact. 1.08. What is the ratio of the Exports(as % of merchandise exports) of Fiji in 2002 to that in 2003?
Offer a terse response. 1.53. What is the ratio of the Exports(as % of merchandise exports) in South Asia in 2002 to that in 2004?
Provide a succinct answer. 0.58. What is the ratio of the Exports(as % of merchandise exports) of Brunei Darussalam in 2002 to that in 2004?
Provide a succinct answer. 1.02. What is the ratio of the Exports(as % of merchandise exports) in Cyprus in 2002 to that in 2004?
Ensure brevity in your answer.  4.01. What is the ratio of the Exports(as % of merchandise exports) in Fiji in 2002 to that in 2004?
Your response must be concise. 0.08. What is the ratio of the Exports(as % of merchandise exports) of South Asia in 2002 to that in 2006?
Keep it short and to the point. 0.32. What is the ratio of the Exports(as % of merchandise exports) of Brunei Darussalam in 2002 to that in 2006?
Your answer should be compact. 0.97. What is the ratio of the Exports(as % of merchandise exports) in Cyprus in 2002 to that in 2006?
Offer a terse response. 67.69. What is the ratio of the Exports(as % of merchandise exports) in Fiji in 2002 to that in 2006?
Provide a short and direct response. 0.01. What is the ratio of the Exports(as % of merchandise exports) in South Asia in 2002 to that in 2012?
Give a very brief answer. 0.25. What is the ratio of the Exports(as % of merchandise exports) in Brunei Darussalam in 2002 to that in 2012?
Give a very brief answer. 0.97. What is the ratio of the Exports(as % of merchandise exports) in Cyprus in 2002 to that in 2012?
Make the answer very short. 3.90e+05. What is the ratio of the Exports(as % of merchandise exports) of Fiji in 2002 to that in 2012?
Your answer should be compact. 0.02. What is the ratio of the Exports(as % of merchandise exports) in South Asia in 2003 to that in 2004?
Keep it short and to the point. 0.74. What is the ratio of the Exports(as % of merchandise exports) of Brunei Darussalam in 2003 to that in 2004?
Provide a short and direct response. 1.03. What is the ratio of the Exports(as % of merchandise exports) in Cyprus in 2003 to that in 2004?
Provide a short and direct response. 3.7. What is the ratio of the Exports(as % of merchandise exports) in Fiji in 2003 to that in 2004?
Keep it short and to the point. 0.06. What is the ratio of the Exports(as % of merchandise exports) in South Asia in 2003 to that in 2006?
Your answer should be compact. 0.4. What is the ratio of the Exports(as % of merchandise exports) in Brunei Darussalam in 2003 to that in 2006?
Offer a terse response. 0.98. What is the ratio of the Exports(as % of merchandise exports) in Cyprus in 2003 to that in 2006?
Your response must be concise. 62.45. What is the ratio of the Exports(as % of merchandise exports) in Fiji in 2003 to that in 2006?
Provide a succinct answer. 0.01. What is the ratio of the Exports(as % of merchandise exports) in South Asia in 2003 to that in 2012?
Provide a succinct answer. 0.31. What is the ratio of the Exports(as % of merchandise exports) of Brunei Darussalam in 2003 to that in 2012?
Make the answer very short. 0.99. What is the ratio of the Exports(as % of merchandise exports) in Cyprus in 2003 to that in 2012?
Your answer should be very brief. 3.60e+05. What is the ratio of the Exports(as % of merchandise exports) in Fiji in 2003 to that in 2012?
Your answer should be compact. 0.01. What is the ratio of the Exports(as % of merchandise exports) of South Asia in 2004 to that in 2006?
Ensure brevity in your answer.  0.54. What is the ratio of the Exports(as % of merchandise exports) of Brunei Darussalam in 2004 to that in 2006?
Make the answer very short. 0.95. What is the ratio of the Exports(as % of merchandise exports) of Cyprus in 2004 to that in 2006?
Make the answer very short. 16.86. What is the ratio of the Exports(as % of merchandise exports) of Fiji in 2004 to that in 2006?
Your response must be concise. 0.1. What is the ratio of the Exports(as % of merchandise exports) in South Asia in 2004 to that in 2012?
Your answer should be compact. 0.42. What is the ratio of the Exports(as % of merchandise exports) in Brunei Darussalam in 2004 to that in 2012?
Provide a succinct answer. 0.95. What is the ratio of the Exports(as % of merchandise exports) of Cyprus in 2004 to that in 2012?
Your response must be concise. 9.71e+04. What is the ratio of the Exports(as % of merchandise exports) of Fiji in 2004 to that in 2012?
Ensure brevity in your answer.  0.18. What is the ratio of the Exports(as % of merchandise exports) in South Asia in 2006 to that in 2012?
Your answer should be compact. 0.78. What is the ratio of the Exports(as % of merchandise exports) in Brunei Darussalam in 2006 to that in 2012?
Offer a very short reply. 1.01. What is the ratio of the Exports(as % of merchandise exports) of Cyprus in 2006 to that in 2012?
Give a very brief answer. 5758.37. What is the ratio of the Exports(as % of merchandise exports) in Fiji in 2006 to that in 2012?
Provide a short and direct response. 1.92. What is the difference between the highest and the second highest Exports(as % of merchandise exports) of South Asia?
Offer a terse response. 3.34. What is the difference between the highest and the second highest Exports(as % of merchandise exports) of Brunei Darussalam?
Offer a terse response. 1.02. What is the difference between the highest and the second highest Exports(as % of merchandise exports) in Cyprus?
Your response must be concise. 1.2. What is the difference between the highest and the second highest Exports(as % of merchandise exports) of Fiji?
Provide a succinct answer. 0.04. What is the difference between the highest and the lowest Exports(as % of merchandise exports) in South Asia?
Make the answer very short. 13.45. What is the difference between the highest and the lowest Exports(as % of merchandise exports) in Brunei Darussalam?
Give a very brief answer. 8.3. What is the difference between the highest and the lowest Exports(as % of merchandise exports) of Cyprus?
Offer a terse response. 5.09. What is the difference between the highest and the lowest Exports(as % of merchandise exports) in Fiji?
Your answer should be very brief. 0.09. 